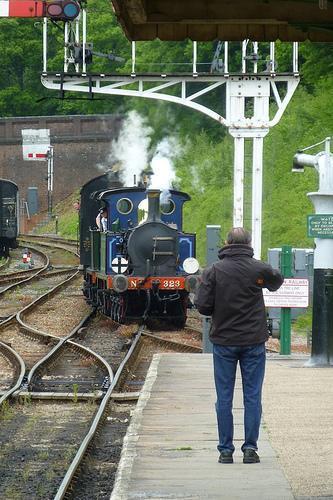How many trains are in this picture?
Give a very brief answer. 2. 